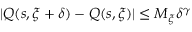Convert formula to latex. <formula><loc_0><loc_0><loc_500><loc_500>| Q ( s , \xi + \delta ) - Q ( s , \xi ) | \leq M _ { \xi } \delta ^ { \gamma }</formula> 